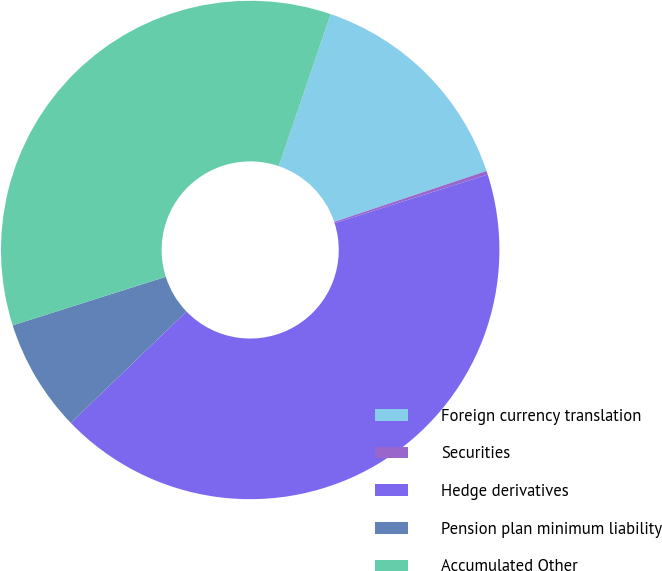Convert chart. <chart><loc_0><loc_0><loc_500><loc_500><pie_chart><fcel>Foreign currency translation<fcel>Securities<fcel>Hedge derivatives<fcel>Pension plan minimum liability<fcel>Accumulated Other<nl><fcel>14.63%<fcel>0.24%<fcel>42.68%<fcel>7.32%<fcel>35.12%<nl></chart> 